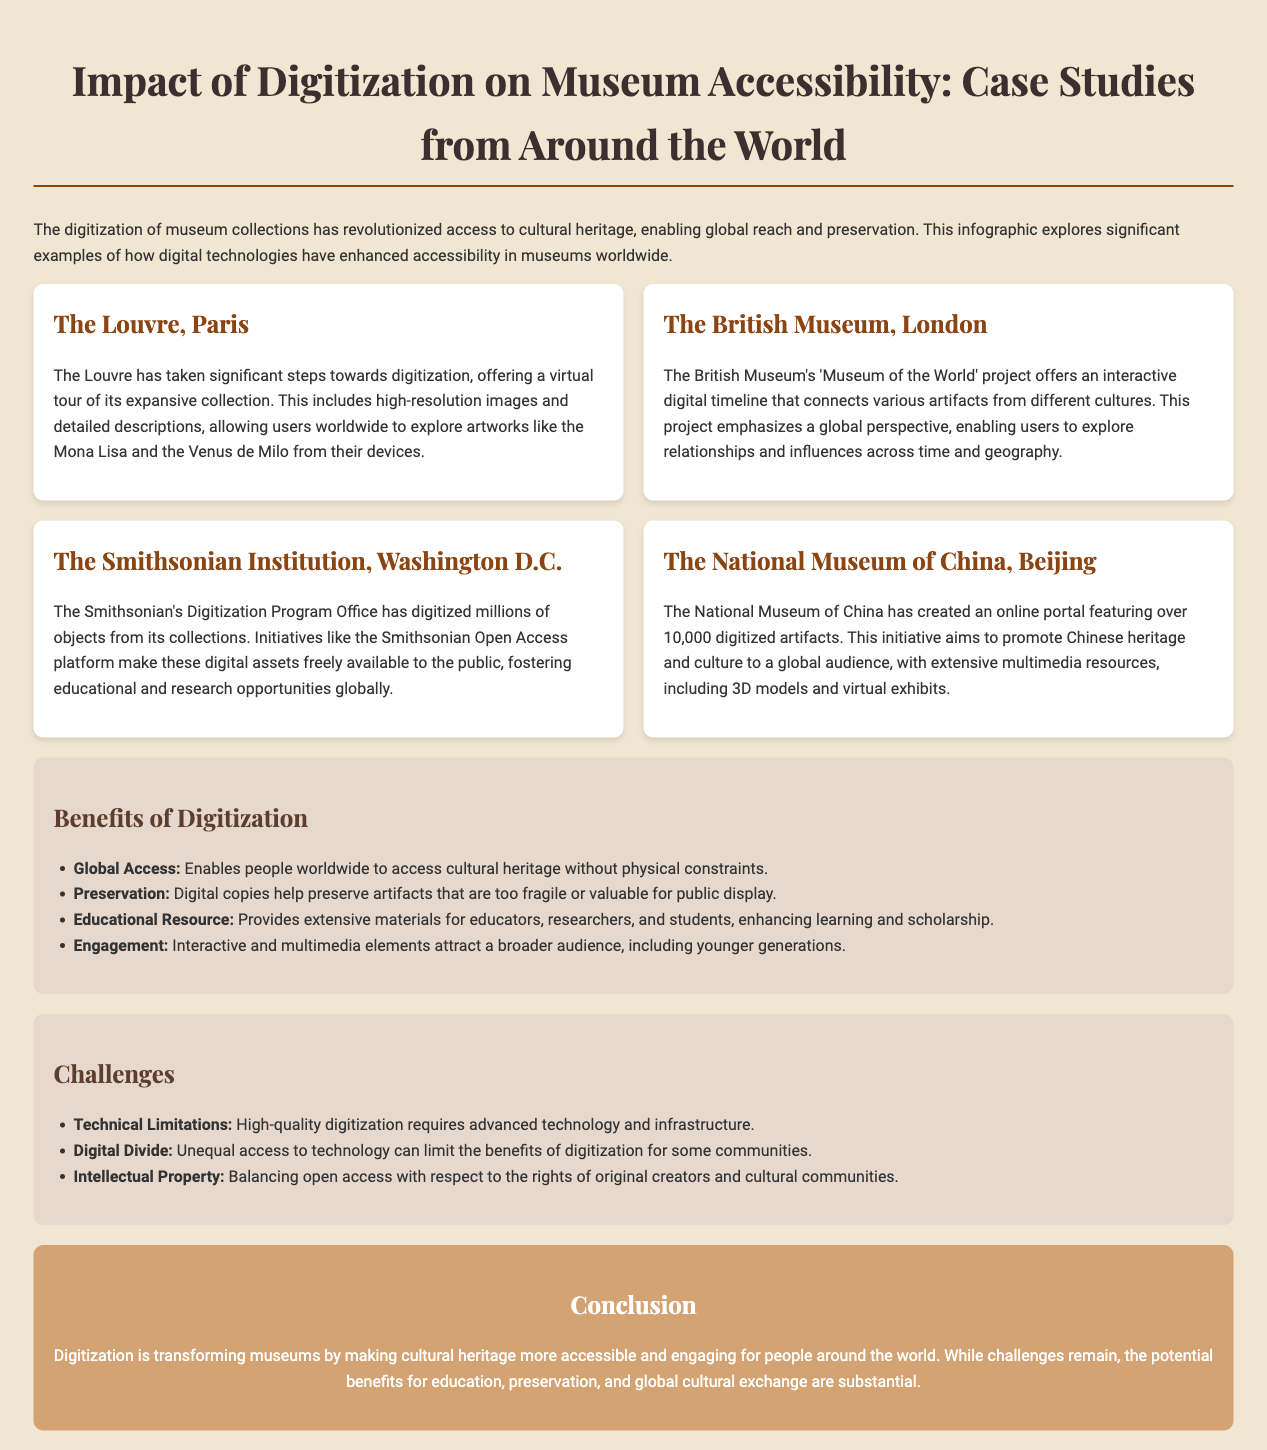What is the title of the infographic? The title is provided at the top of the document, identifying the main focus of the infographic.
Answer: Impact of Digitization on Museum Accessibility: Case Studies from Around the World How many case studies are presented? The document includes a section outlining various museums with digitization efforts, listing four specific case studies.
Answer: Four What project does the British Museum feature? The British Museum's project is highlighted in the section describing its contributions to global museum accessibility through a specific initiative.
Answer: Museum of the World How many digitized artifacts does the National Museum of China have? The specific number of artifacts digitized by the National Museum of China is mentioned in its case study description.
Answer: Over 10,000 What is one benefit of digitization mentioned in the document? The benefits section lists several advantages, demonstrating the positive impacts of digitization on accessibility and education.
Answer: Global Access What challenge related to technology is mentioned? The challenges section discusses several obstacles faced during the digitization process, particularly in terms of the technology used.
Answer: Technical Limitations What aspect does the conclusion highlight about digitization? The conclusion is a summary that emphasizes key takeaways regarding the overall impact of digitization on museums.
Answer: Transforming museums Which museum offers a virtual tour? The document describes which museum provides a virtual experience of its collection, making it accessible online.
Answer: The Louvre 